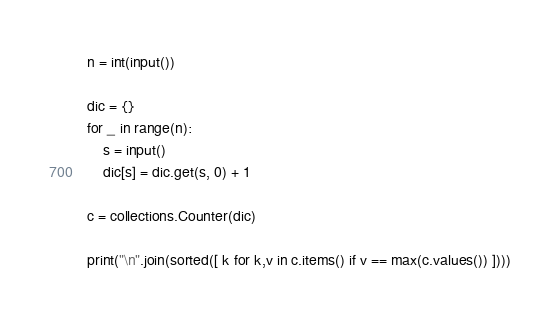Convert code to text. <code><loc_0><loc_0><loc_500><loc_500><_Python_>n = int(input())

dic = {}
for _ in range(n):
    s = input()
    dic[s] = dic.get(s, 0) + 1

c = collections.Counter(dic)

print("\n".join(sorted([ k for k,v in c.items() if v == max(c.values()) ])))</code> 